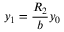Convert formula to latex. <formula><loc_0><loc_0><loc_500><loc_500>y _ { 1 } = \frac { R _ { 2 } } { b } y _ { 0 }</formula> 